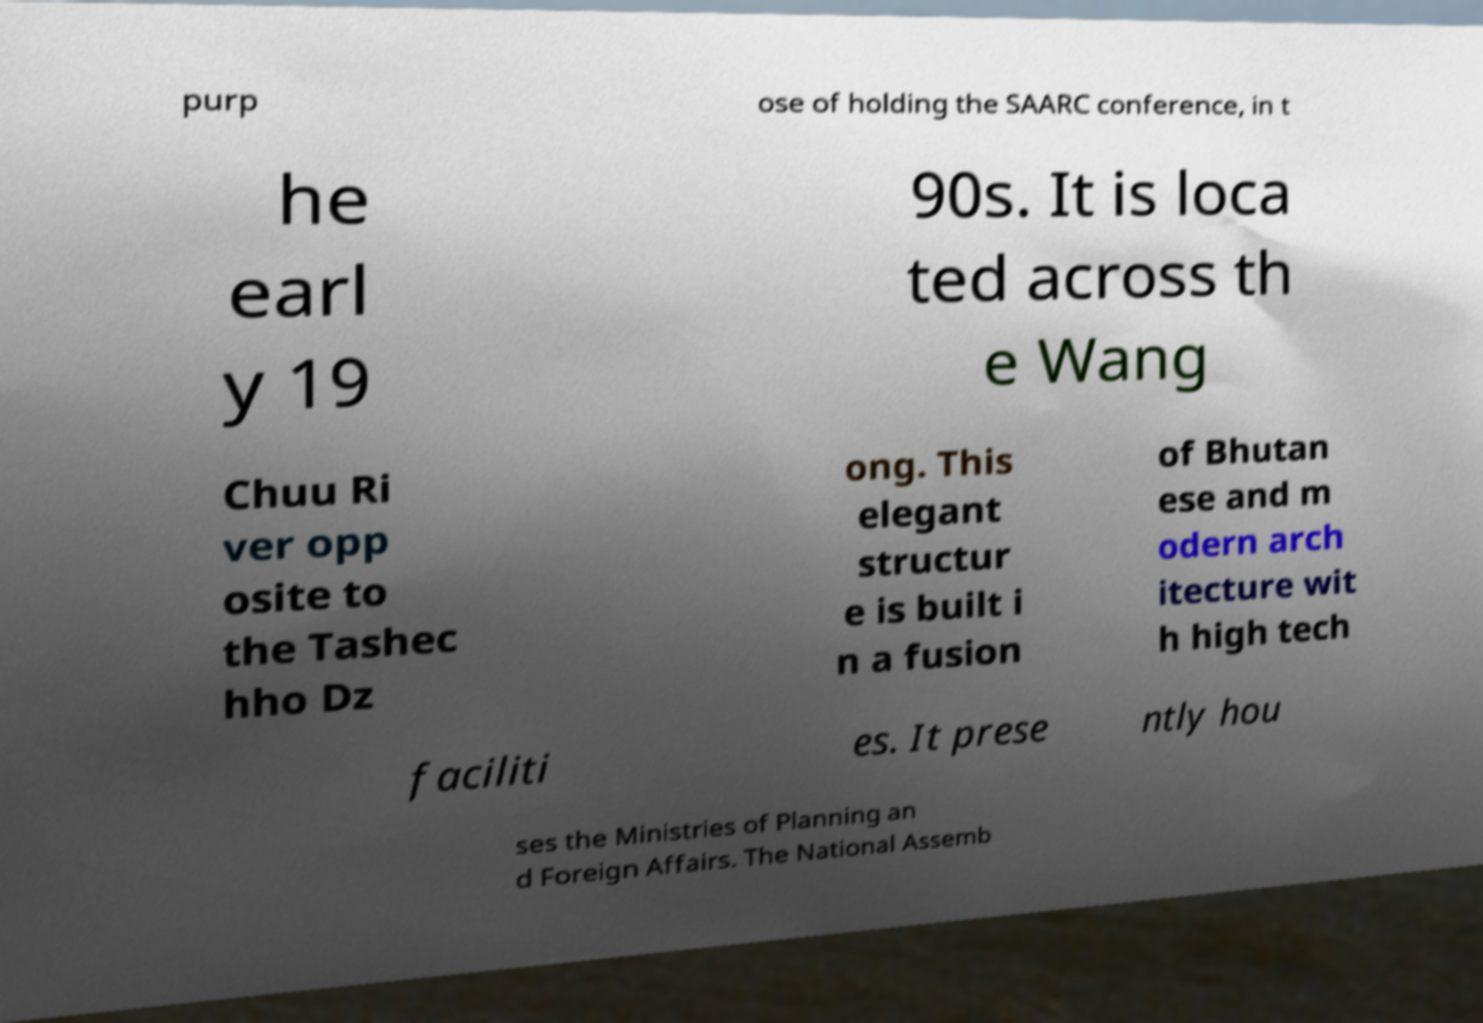Could you assist in decoding the text presented in this image and type it out clearly? purp ose of holding the SAARC conference, in t he earl y 19 90s. It is loca ted across th e Wang Chuu Ri ver opp osite to the Tashec hho Dz ong. This elegant structur e is built i n a fusion of Bhutan ese and m odern arch itecture wit h high tech faciliti es. It prese ntly hou ses the Ministries of Planning an d Foreign Affairs. The National Assemb 